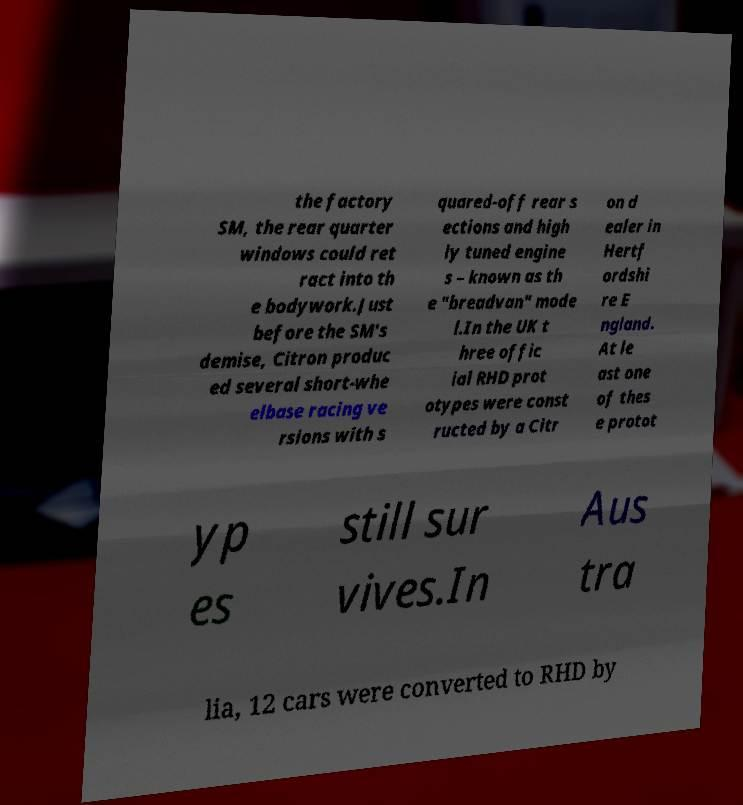For documentation purposes, I need the text within this image transcribed. Could you provide that? the factory SM, the rear quarter windows could ret ract into th e bodywork.Just before the SM's demise, Citron produc ed several short-whe elbase racing ve rsions with s quared-off rear s ections and high ly tuned engine s – known as th e "breadvan" mode l.In the UK t hree offic ial RHD prot otypes were const ructed by a Citr on d ealer in Hertf ordshi re E ngland. At le ast one of thes e protot yp es still sur vives.In Aus tra lia, 12 cars were converted to RHD by 